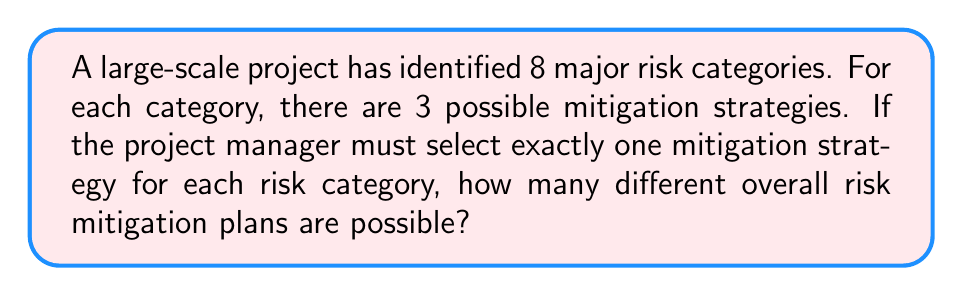Give your solution to this math problem. Let's approach this step-by-step:

1) We have 8 risk categories, and for each category, we need to choose 1 out of 3 possible mitigation strategies.

2) This scenario is a perfect example of the Multiplication Principle in combinatorics. When we have a series of independent choices, and we want to know the total number of possible outcomes, we multiply the number of options for each choice.

3) In this case:
   - For the first risk category, we have 3 choices
   - For the second risk category, we again have 3 choices
   - This continues for all 8 risk categories

4) Mathematically, this can be expressed as:

   $$ 3 \times 3 \times 3 \times 3 \times 3 \times 3 \times 3 \times 3 $$

5) This is equivalent to:

   $$ 3^8 $$

6) To calculate this:
   $$ 3^8 = 3 \times 3 \times 3 \times 3 \times 3 \times 3 \times 3 \times 3 = 6,561 $$

Therefore, there are 6,561 different possible overall risk mitigation plans.
Answer: 6,561 possible risk mitigation plans 